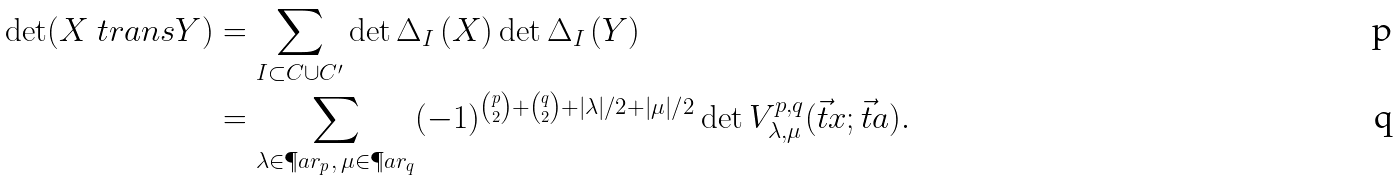Convert formula to latex. <formula><loc_0><loc_0><loc_500><loc_500>\det ( X \ t r a n s Y ) & = \sum _ { I \subset C \cup C ^ { \prime } } \det \Delta _ { I } \left ( X \right ) \det \Delta _ { I } \left ( Y \right ) \\ & = \sum _ { \lambda \in \P a r _ { p } , \, \mu \in \P a r _ { q } } ( - 1 ) ^ { \binom { p } 2 + \binom { q } 2 + | \lambda | / 2 + | \mu | / 2 } \det V ^ { p , q } _ { \lambda , \mu } ( \vec { t } x ; \vec { t } a ) .</formula> 